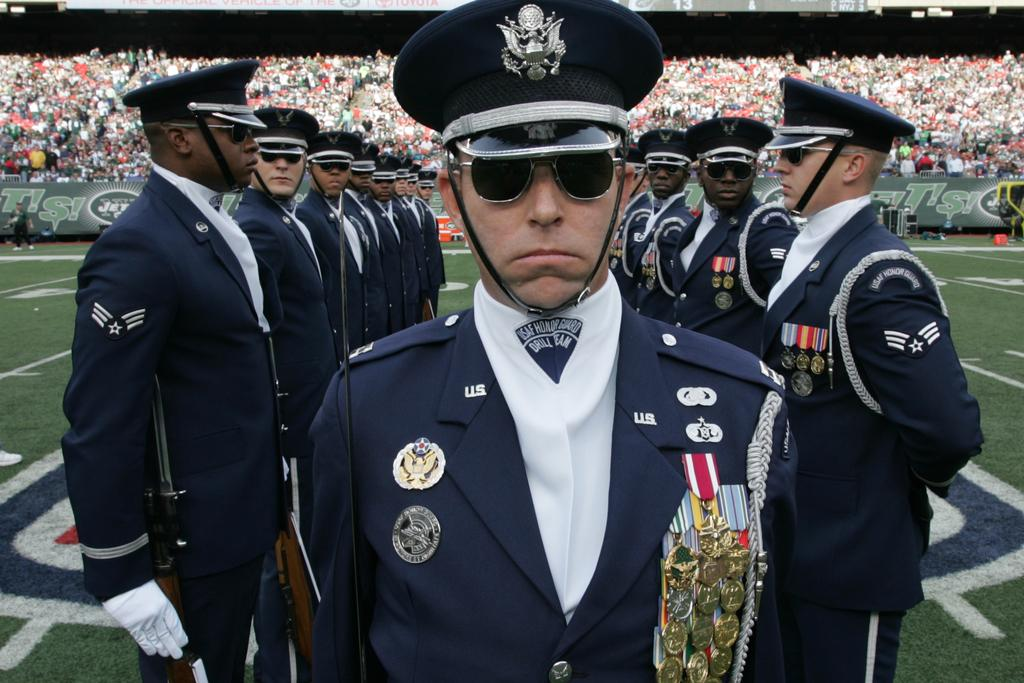What activity are the officers performing in the image? The officers are performing a parade in the image. Where is the parade taking place? The parade is taking place on a ground. Can you describe the people in the background of the image? There is an audience seated in the background of the image. What type of chalk is being used by the officers during the parade? There is no chalk present in the image; the officers are performing a parade without any chalk. Can you tell me the purpose of the pickle in the image? There is no pickle present in the image, so it cannot serve any purpose in this context. 